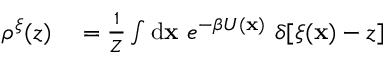<formula> <loc_0><loc_0><loc_500><loc_500>\begin{array} { r l } { \rho ^ { \xi } ( z ) } & = \frac { 1 } { Z } \int d { x } \ e ^ { - \beta U ( { x } ) } \ \delta [ \xi ( { x } ) - z ] } \end{array}</formula> 